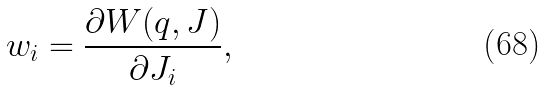<formula> <loc_0><loc_0><loc_500><loc_500>w _ { i } = \frac { \partial W ( q , J ) } { \partial J _ { i } } ,</formula> 